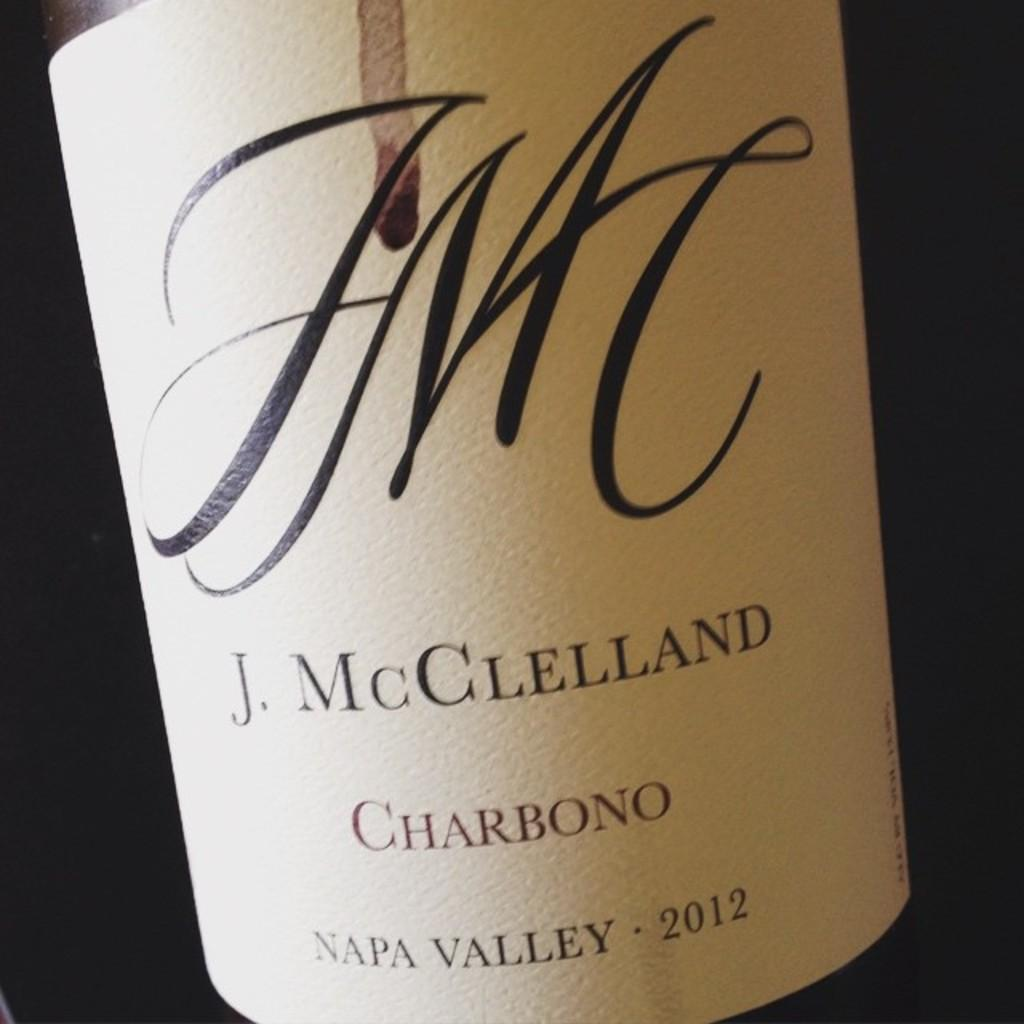<image>
Write a terse but informative summary of the picture. The logo for a J. MCClelland Charbono with some wine dripping down from the top. 